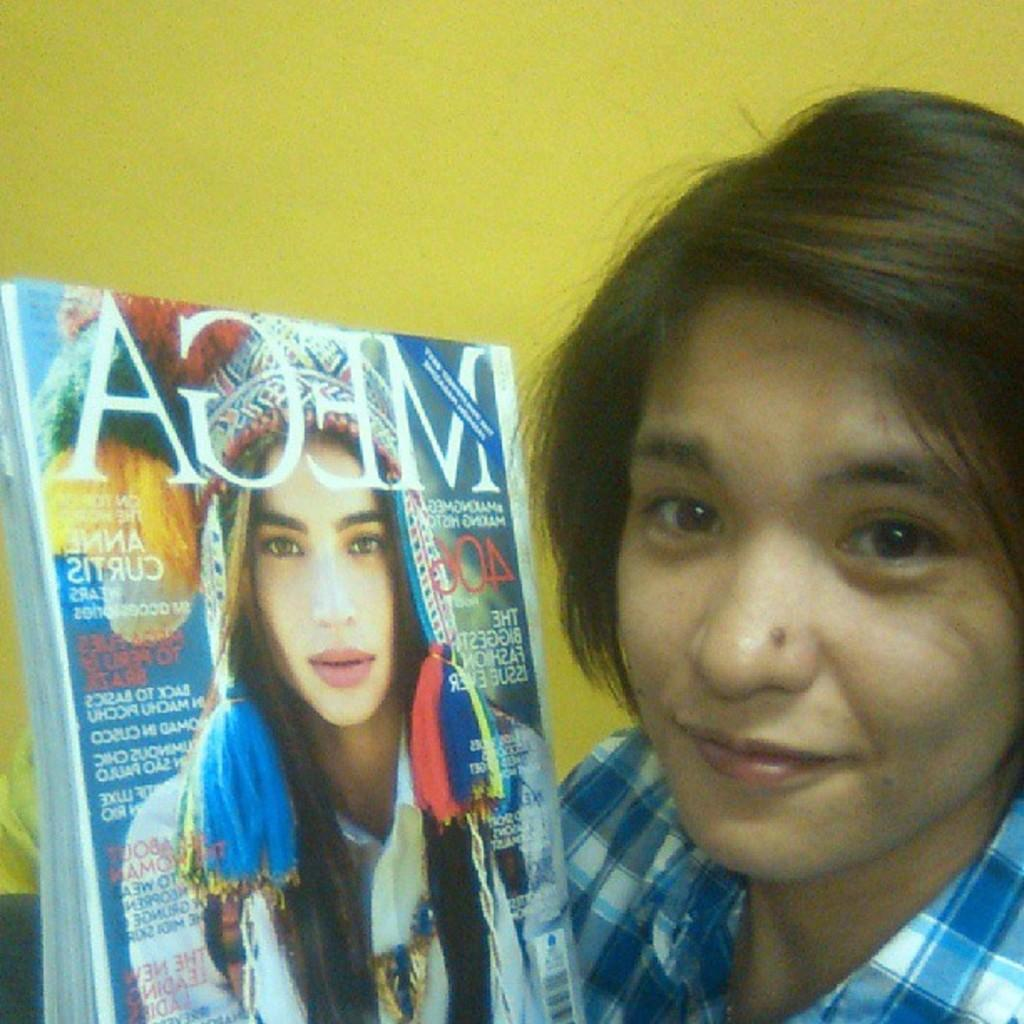Who is present in the image? There is a woman in the image. What is the woman holding? The woman is holding a book. Can you describe the book? There is a picture of a woman on the book, and there is text on the book. What color is the wall in the background of the image? The wall in the background of the image is yellow. What type of wine is being served in the image? There is no wine present in the image; it features a woman holding a book with a picture of a woman on it. What color is the paint used on the stew in the image? There is no stew or paint present in the image. 